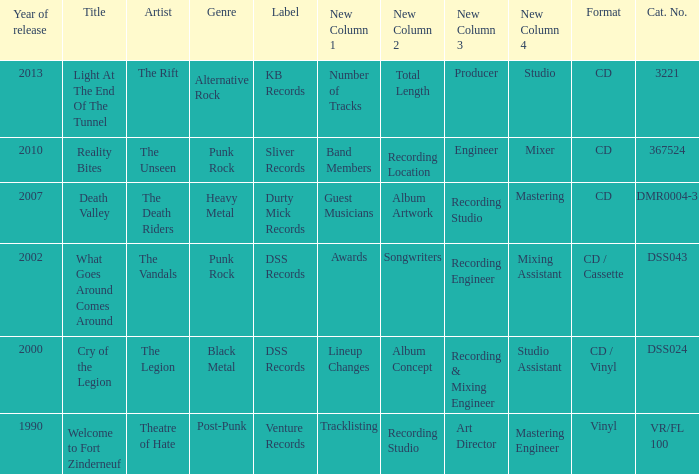What is the latest year of the album with the release title death valley? 2007.0. 